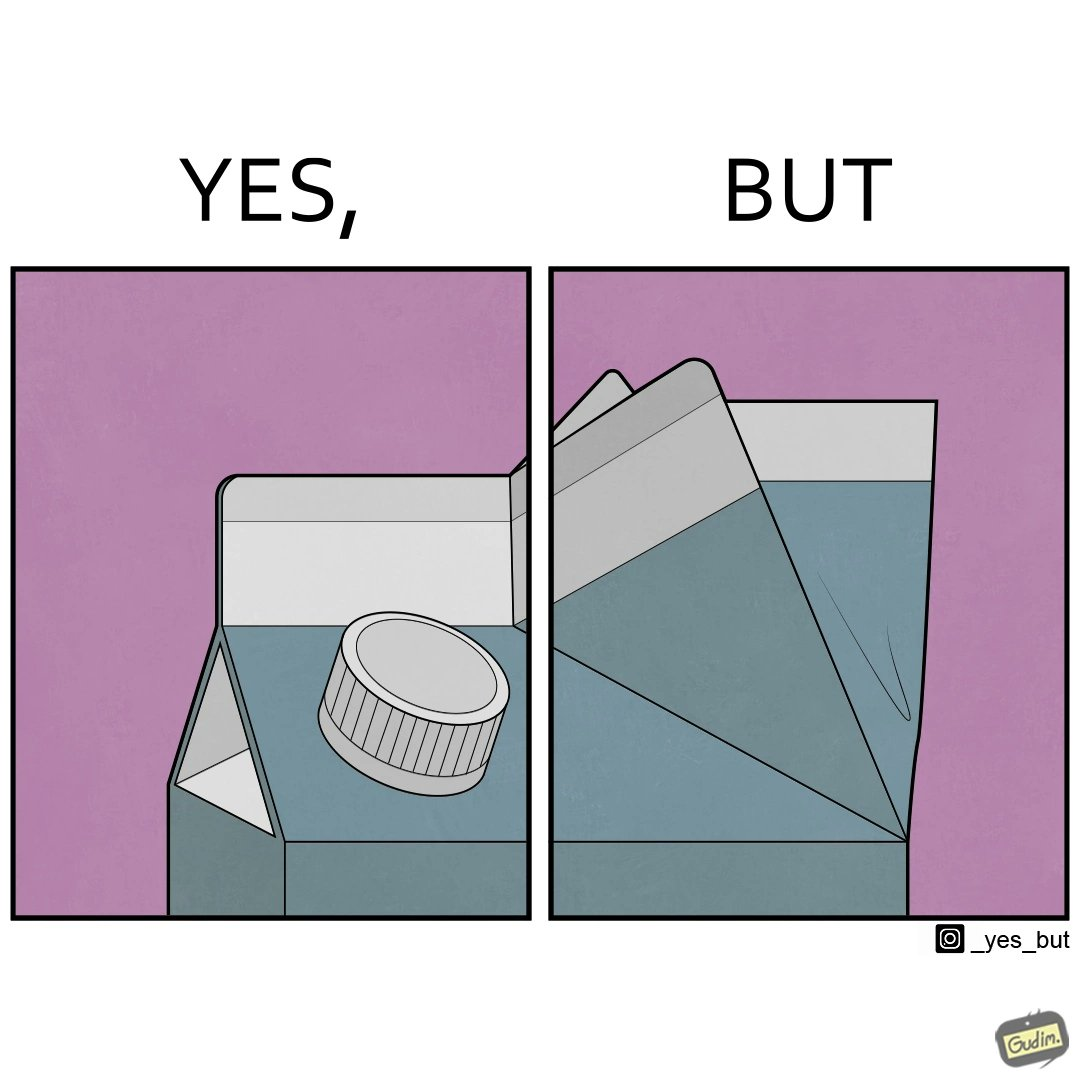Describe what you see in this image. The image is ironic, because on the one side tetra packs have cap or lid for opening but on the other side the folded end seems inconvenient to handle 